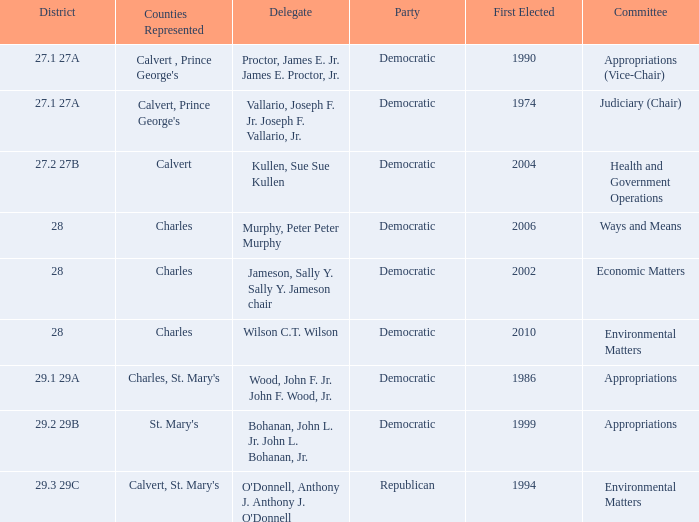When first elected was 2006, who was the delegate? Murphy, Peter Peter Murphy. 